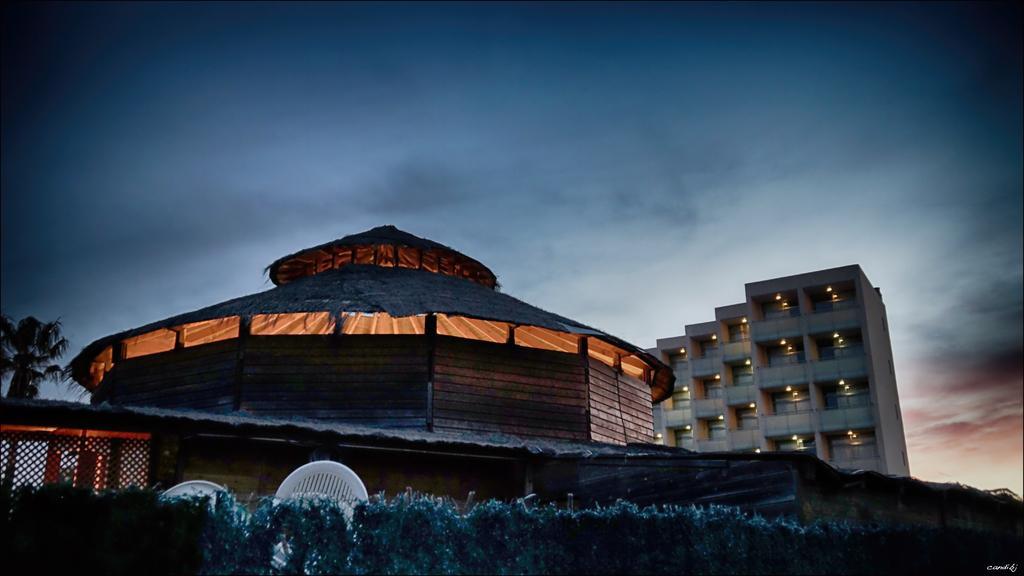Describe this image in one or two sentences. In this image, I can see a building with the lights. This looks like a shelter with a roof. I think these are the chairs, which are white in color. I can see the bushes. On the left side of the image, that looks like a tree. This is the sky. 